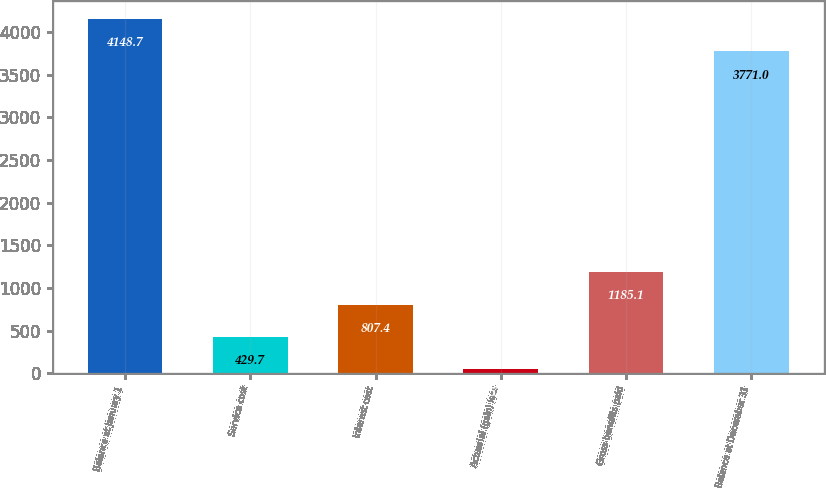Convert chart to OTSL. <chart><loc_0><loc_0><loc_500><loc_500><bar_chart><fcel>Balance at January 1<fcel>Service cost<fcel>Interest cost<fcel>Actuarial (gain) loss<fcel>Gross benefits paid<fcel>Balance at December 31<nl><fcel>4148.7<fcel>429.7<fcel>807.4<fcel>52<fcel>1185.1<fcel>3771<nl></chart> 